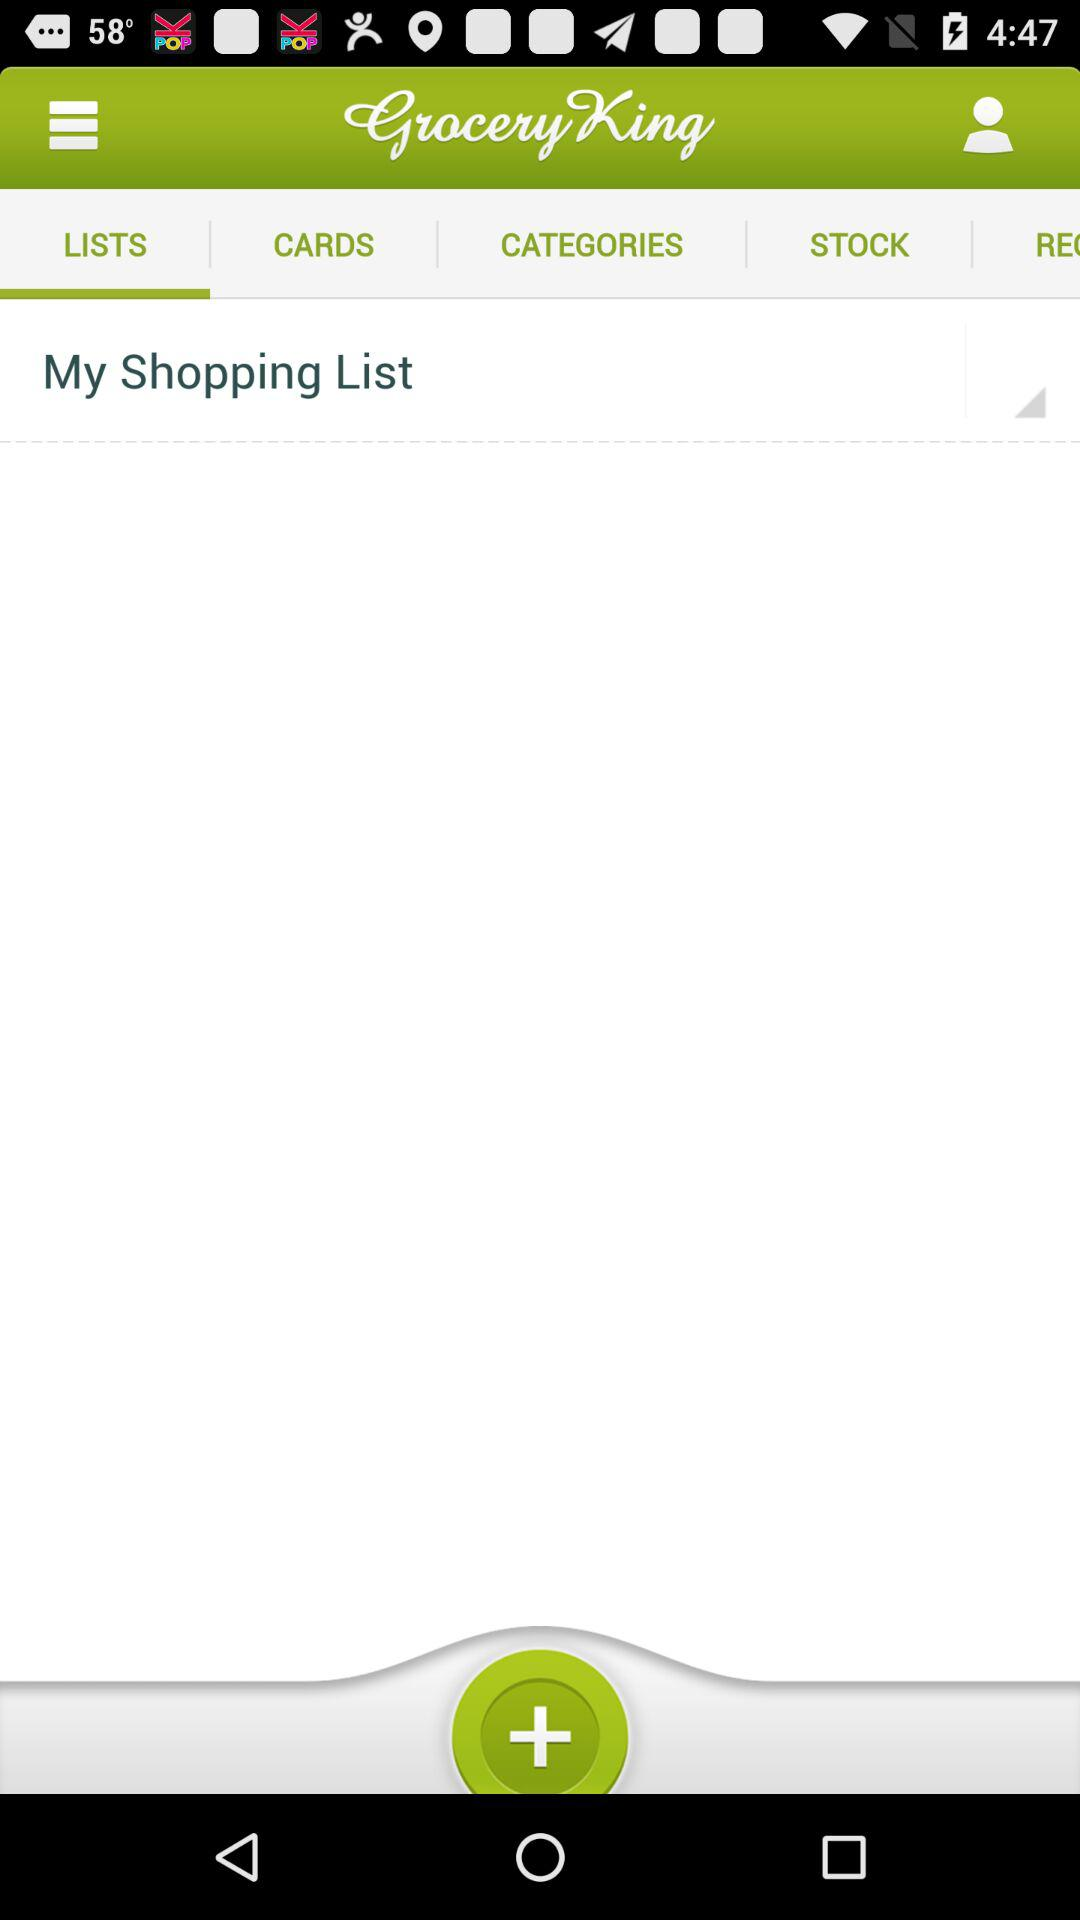What is the application name? The application name is "Grocery King". 